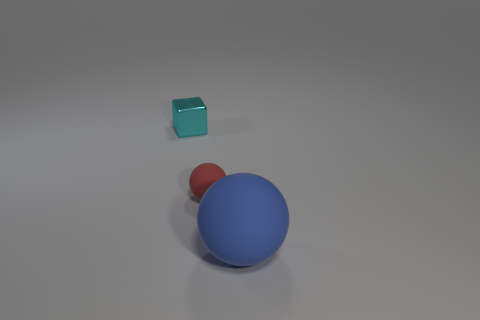Subtract all blue spheres. How many spheres are left? 1 Subtract 2 balls. How many balls are left? 0 Add 3 metal cubes. How many objects exist? 6 Subtract all blocks. How many objects are left? 2 Subtract 0 yellow cylinders. How many objects are left? 3 Subtract all blue blocks. Subtract all yellow balls. How many blocks are left? 1 Subtract all cyan cylinders. How many red spheres are left? 1 Subtract all small red rubber things. Subtract all tiny metallic cubes. How many objects are left? 1 Add 2 balls. How many balls are left? 4 Add 1 small metal things. How many small metal things exist? 2 